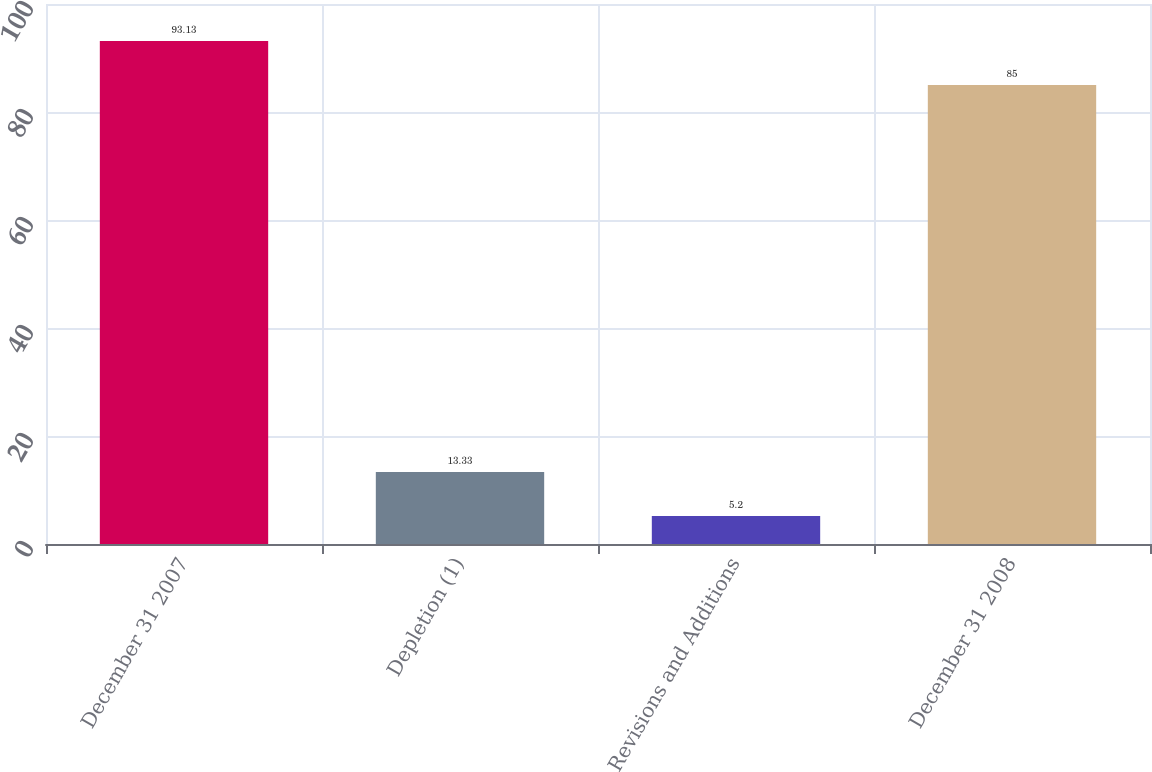<chart> <loc_0><loc_0><loc_500><loc_500><bar_chart><fcel>December 31 2007<fcel>Depletion (1)<fcel>Revisions and Additions<fcel>December 31 2008<nl><fcel>93.13<fcel>13.33<fcel>5.2<fcel>85<nl></chart> 